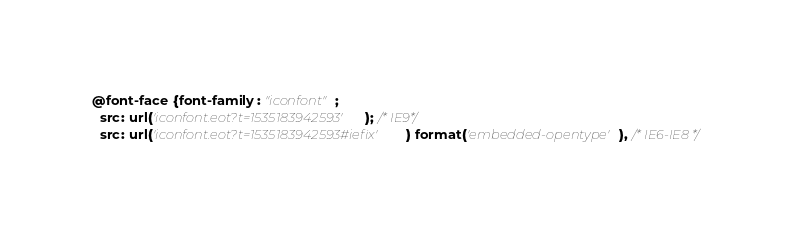<code> <loc_0><loc_0><loc_500><loc_500><_CSS_>
@font-face {font-family: "iconfont";
  src: url('iconfont.eot?t=1535183942593'); /* IE9*/
  src: url('iconfont.eot?t=1535183942593#iefix') format('embedded-opentype'), /* IE6-IE8 */</code> 